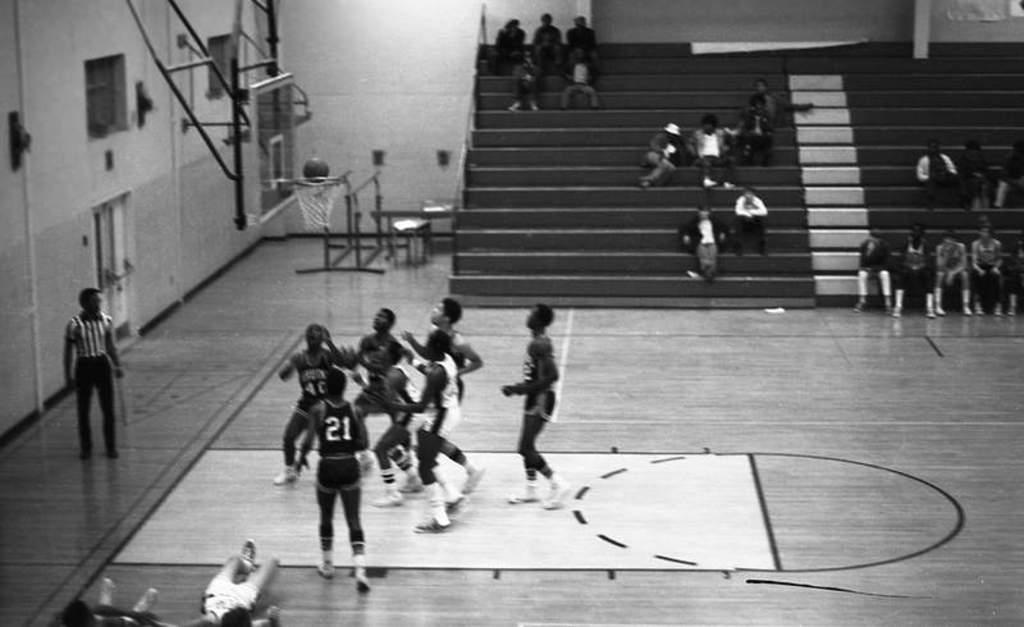<image>
Describe the image concisely. A basketball going on in a gym with one player have 21 on his jersey. 